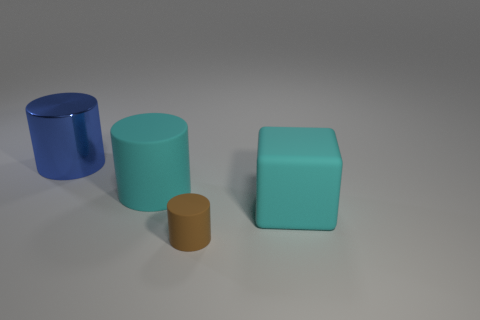Are there any other things that are the same size as the brown object?
Your response must be concise. No. The cyan matte thing on the right side of the rubber cylinder in front of the big cylinder that is in front of the metallic cylinder is what shape?
Provide a short and direct response. Cube. There is another metallic object that is the same shape as the tiny brown object; what color is it?
Offer a terse response. Blue. What is the color of the big cylinder that is behind the large cylinder in front of the metallic cylinder?
Offer a terse response. Blue. What size is the cyan object that is the same shape as the big blue metallic object?
Provide a short and direct response. Large. How many blue cylinders have the same material as the brown object?
Provide a succinct answer. 0. How many brown matte cylinders are right of the blue object that is left of the cyan block?
Ensure brevity in your answer.  1. There is a blue metal cylinder; are there any big cylinders in front of it?
Offer a very short reply. Yes. There is a cyan rubber object left of the brown cylinder; does it have the same shape as the large metallic object?
Offer a terse response. Yes. There is a big object that is the same color as the matte cube; what is its material?
Provide a succinct answer. Rubber. 